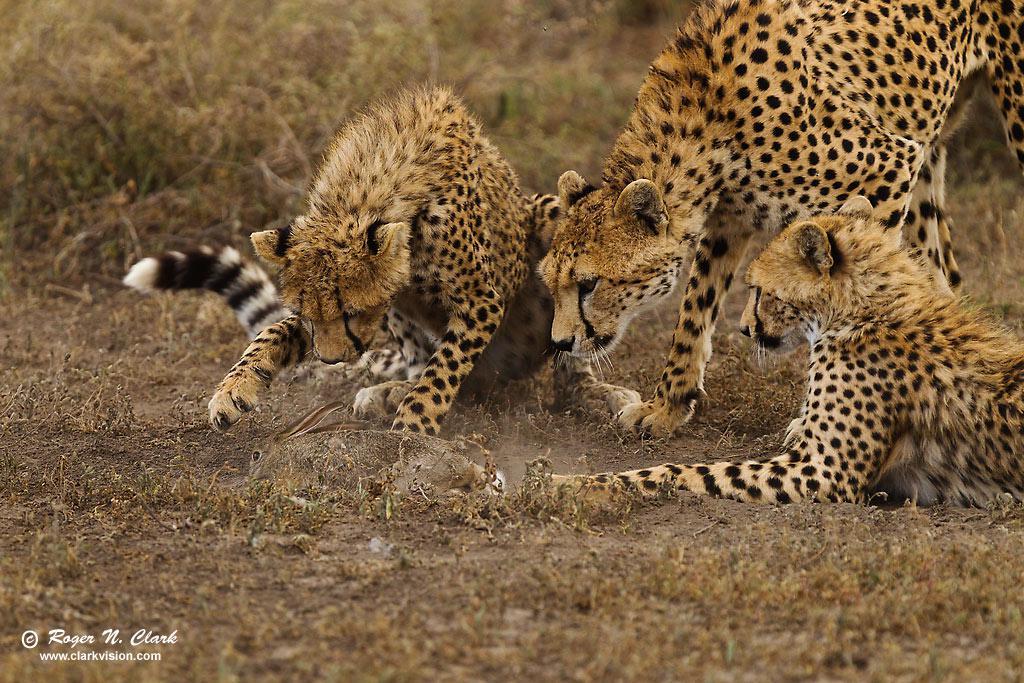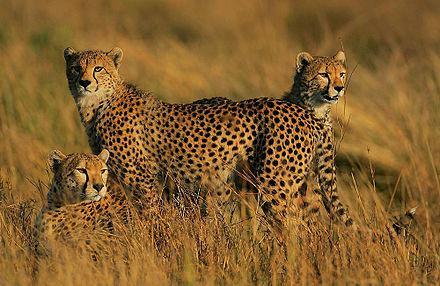The first image is the image on the left, the second image is the image on the right. For the images displayed, is the sentence "Two of the cats in the image on the right are lying on the ground." factually correct? Answer yes or no. No. The first image is the image on the left, the second image is the image on the right. Examine the images to the left and right. Is the description "The right image contains no more than two cheetahs." accurate? Answer yes or no. No. 